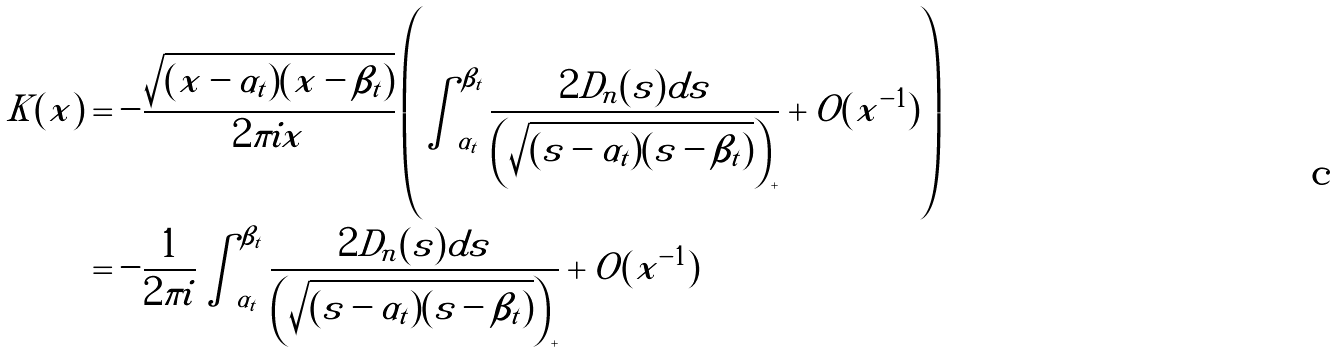Convert formula to latex. <formula><loc_0><loc_0><loc_500><loc_500>K ( x ) & = - \frac { \sqrt { ( x - \alpha _ { t } ) ( x - \beta _ { t } ) } } { 2 \pi i x } \left ( \int _ { \alpha _ { t } } ^ { \beta _ { t } } \frac { 2 D _ { n } ( s ) d s } { \left ( \sqrt { ( s - \alpha _ { t } ) ( s - \beta _ { t } ) } \right ) _ { + } } + O ( x ^ { - 1 } ) \right ) \\ & = - \frac { 1 } { 2 \pi i } \int _ { \alpha _ { t } } ^ { \beta _ { t } } \frac { 2 D _ { n } ( s ) d s } { \left ( \sqrt { ( s - \alpha _ { t } ) ( s - \beta _ { t } ) } \right ) _ { + } } + O ( x ^ { - 1 } )</formula> 